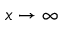Convert formula to latex. <formula><loc_0><loc_0><loc_500><loc_500>x \to \infty</formula> 